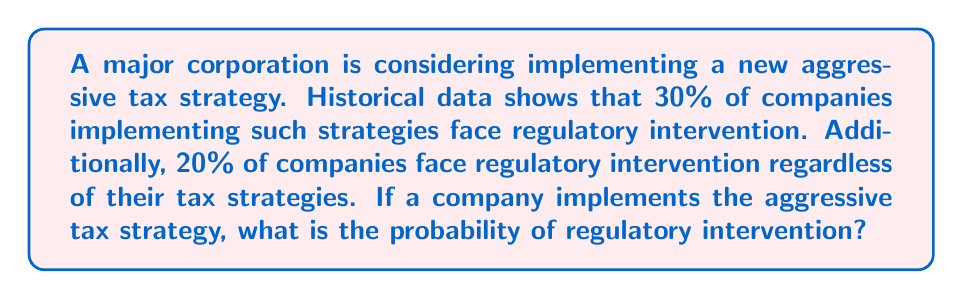Show me your answer to this math problem. Let's approach this step-by-step using conditional probability:

1) Define events:
   A: Company implements aggressive tax strategy
   R: Regulatory intervention occurs

2) Given information:
   P(R|A) = 0.30 (probability of regulatory intervention given aggressive strategy)
   P(R) = 0.20 (overall probability of regulatory intervention)

3) We need to find P(R|A), which is already given as 0.30.

4) However, to demonstrate understanding, we can verify this using Bayes' Theorem:

   $$P(R|A) = \frac{P(A|R) \cdot P(R)}{P(A)}$$

5) We know P(R), but we need P(A|R) and P(A). Let's assume P(A) = 0.50 (50% of companies implement aggressive strategies).

6) We can find P(A|R) using the given information:

   $$P(R) = P(R|A) \cdot P(A) + P(R|\text{not A}) \cdot P(\text{not A})$$
   $$0.20 = 0.30 \cdot 0.50 + P(R|\text{not A}) \cdot 0.50$$
   $$P(R|\text{not A}) = 0.10$$

7) Now we can calculate P(A|R):

   $$P(A|R) = \frac{P(R|A) \cdot P(A)}{P(R)} = \frac{0.30 \cdot 0.50}{0.20} = 0.75$$

8) Plugging back into Bayes' Theorem:

   $$P(R|A) = \frac{0.75 \cdot 0.20}{0.50} = 0.30$$

This verifies the given probability of 30%.
Answer: 0.30 